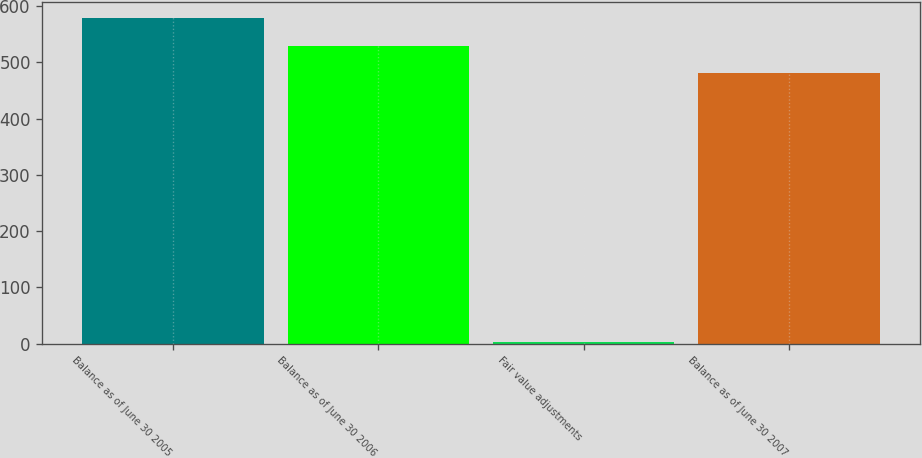Convert chart to OTSL. <chart><loc_0><loc_0><loc_500><loc_500><bar_chart><fcel>Balance as of June 30 2005<fcel>Balance as of June 30 2006<fcel>Fair value adjustments<fcel>Balance as of June 30 2007<nl><fcel>578.2<fcel>529.2<fcel>2.1<fcel>480.2<nl></chart> 